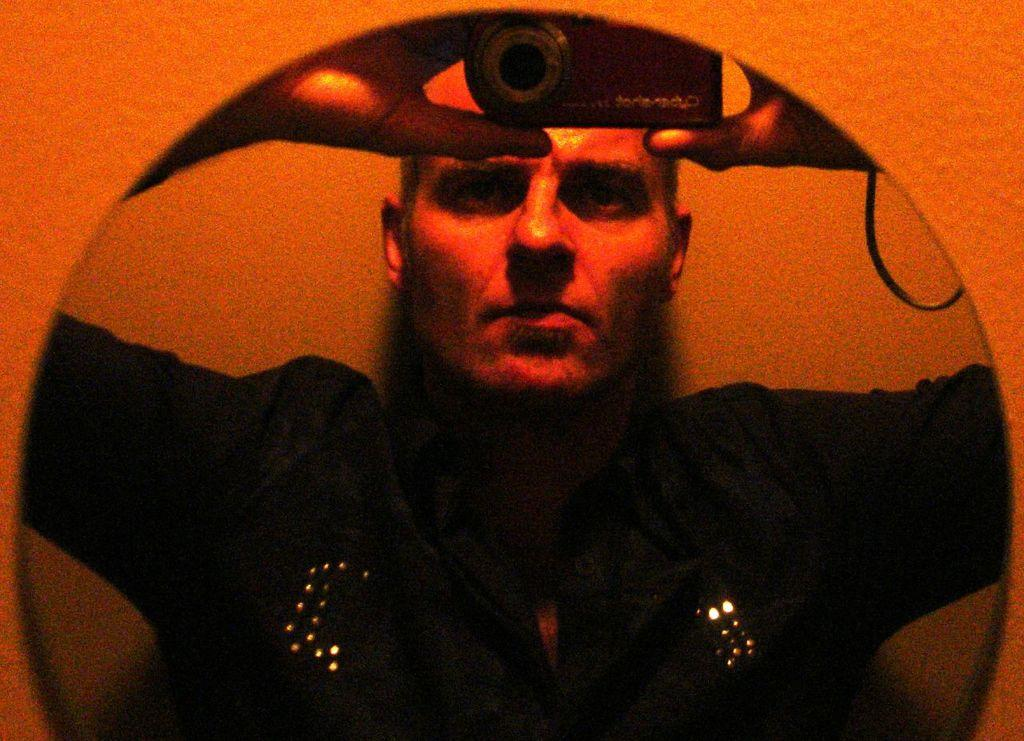What color is the wall in the image? The wall in the image is orange colored. What is attached to the wall? There is a mirror attached to the wall. What can be seen in the mirror's reflection? The reflection of a person wearing a black colored dress is visible in the mirror. What is the person holding in the mirror's reflection? The person is holding a camera in the mirror's reflection. What type of body is visible in the image? There is no body present in the image; it features a wall, a mirror, and a reflection of a person wearing a black dress holding a camera. Can you see a cub in the image? There is no cub present in the image. 